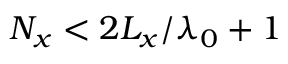Convert formula to latex. <formula><loc_0><loc_0><loc_500><loc_500>N _ { x } < 2 L _ { x } / \lambda _ { 0 } + 1</formula> 